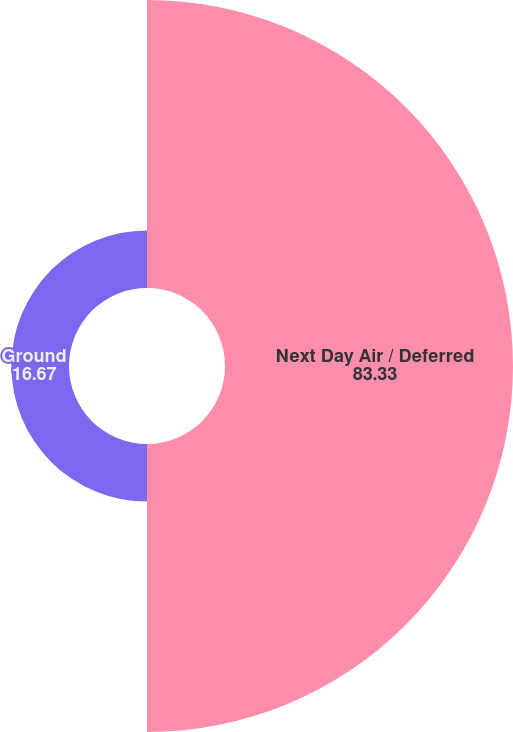Convert chart to OTSL. <chart><loc_0><loc_0><loc_500><loc_500><pie_chart><fcel>Next Day Air / Deferred<fcel>Ground<nl><fcel>83.33%<fcel>16.67%<nl></chart> 